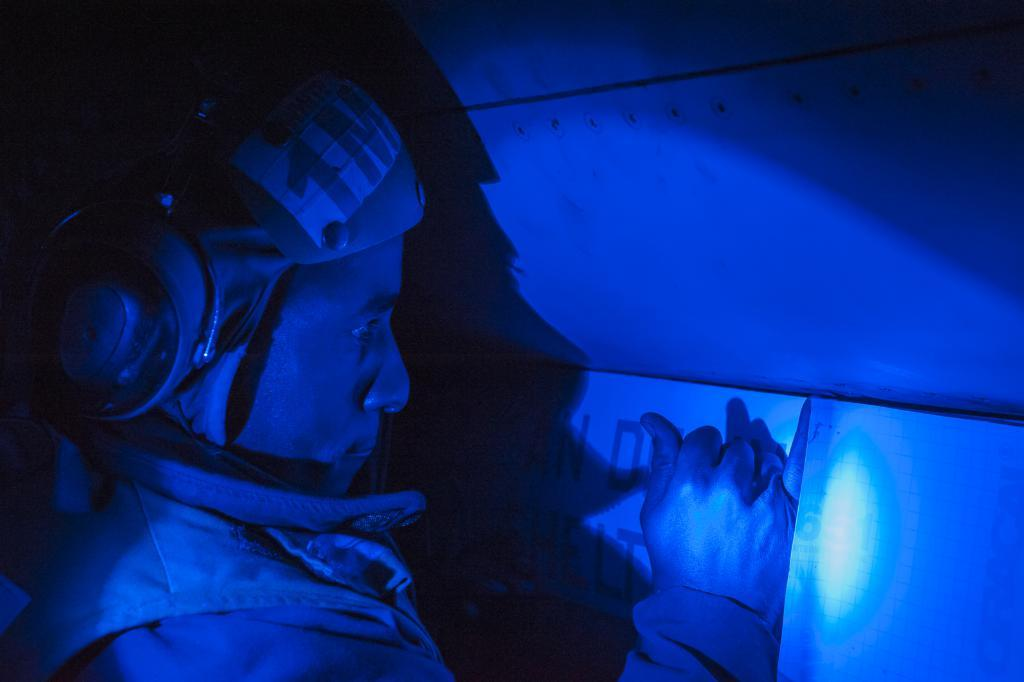What is the main subject of the image? The main subject of the image is a man. What is the man doing in the image? The man is standing in the image. What is the man wearing on his head? The man is wearing a headset in the image. What type of goose can be seen flying in the image? There is no goose present in the image; it only features a man standing and wearing a headset. What month is depicted in the image? The image does not depict a specific month; it only shows a man standing and wearing a headset. 